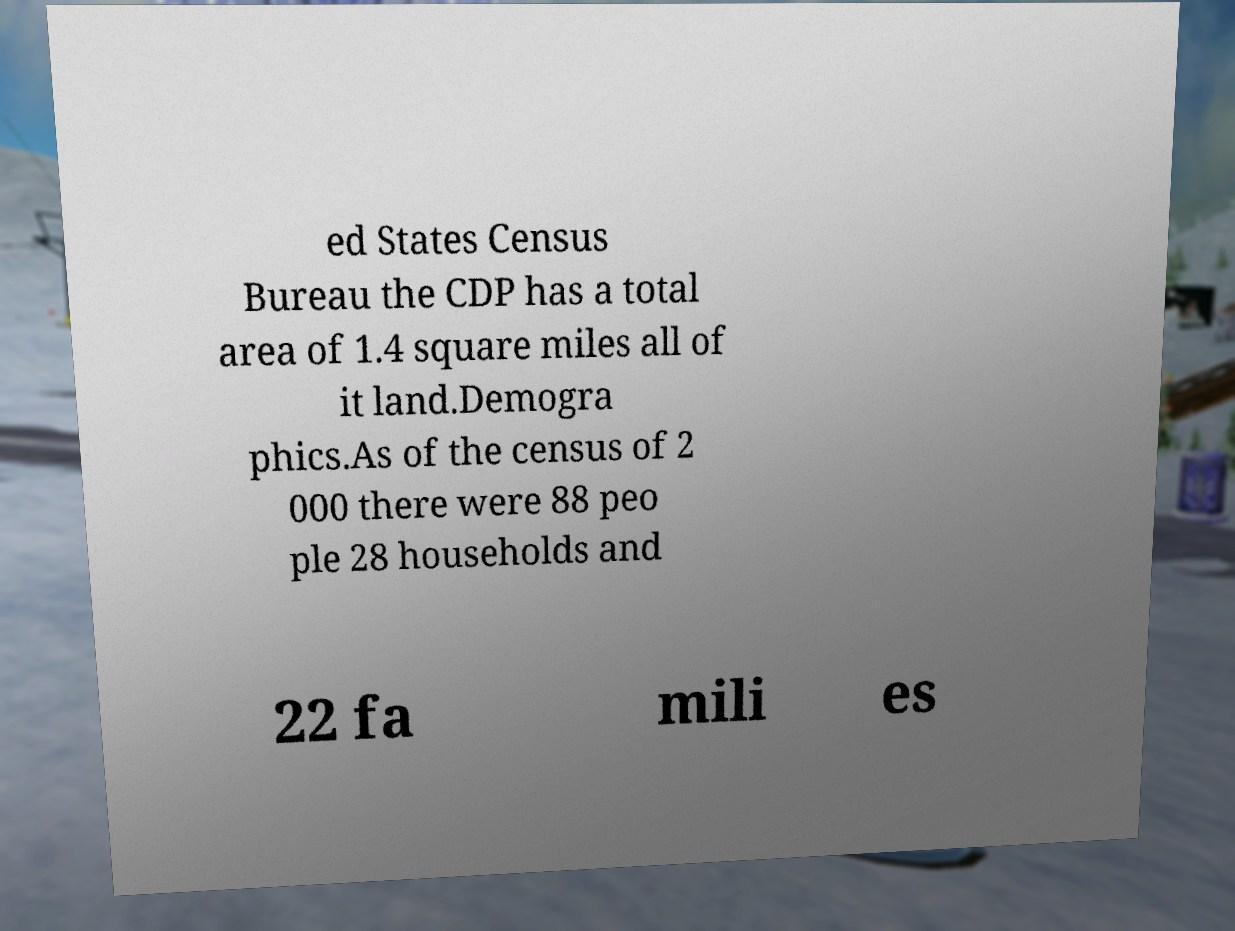Could you assist in decoding the text presented in this image and type it out clearly? ed States Census Bureau the CDP has a total area of 1.4 square miles all of it land.Demogra phics.As of the census of 2 000 there were 88 peo ple 28 households and 22 fa mili es 